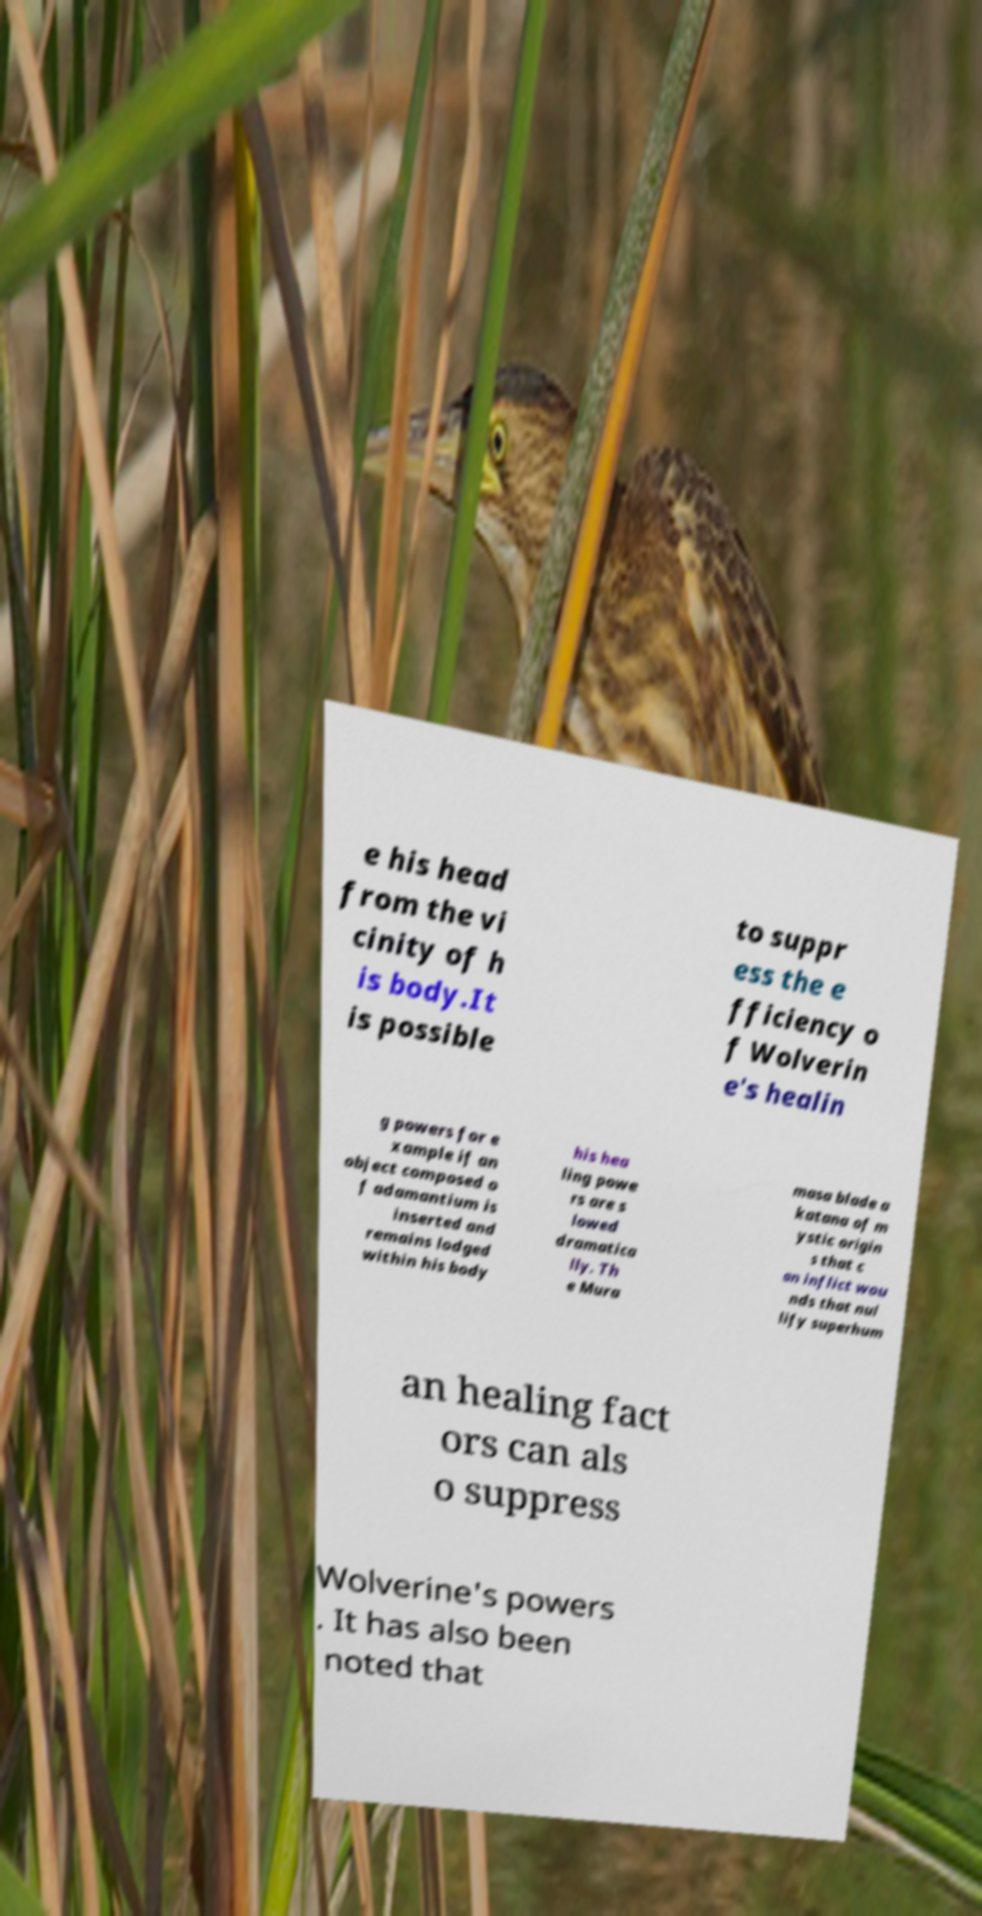For documentation purposes, I need the text within this image transcribed. Could you provide that? e his head from the vi cinity of h is body.It is possible to suppr ess the e fficiency o f Wolverin e's healin g powers for e xample if an object composed o f adamantium is inserted and remains lodged within his body his hea ling powe rs are s lowed dramatica lly. Th e Mura masa blade a katana of m ystic origin s that c an inflict wou nds that nul lify superhum an healing fact ors can als o suppress Wolverine's powers . It has also been noted that 